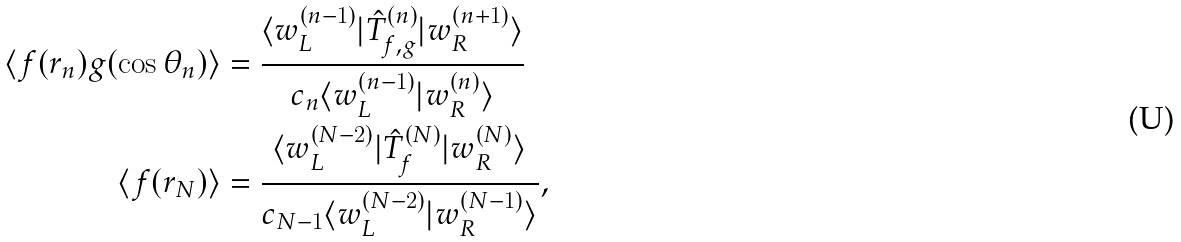Convert formula to latex. <formula><loc_0><loc_0><loc_500><loc_500>\langle f ( r _ { n } ) g ( \cos \theta _ { n } ) \rangle & = \frac { \langle w ^ { ( n - 1 ) } _ { L } | \hat { T } ^ { ( n ) } _ { f , g } | w ^ { ( n + 1 ) } _ { R } \rangle } { c _ { n } \langle w ^ { ( n - 1 ) } _ { L } | w ^ { ( n ) } _ { R } \rangle } \\ \langle f ( r _ { N } ) \rangle & = \frac { \langle w ^ { ( N - 2 ) } _ { L } | \hat { T } ^ { ( N ) } _ { f } | w ^ { ( N ) } _ { R } \rangle } { c _ { N - 1 } \langle w ^ { ( N - 2 ) } _ { L } | w ^ { ( N - 1 ) } _ { R } \rangle } ,</formula> 